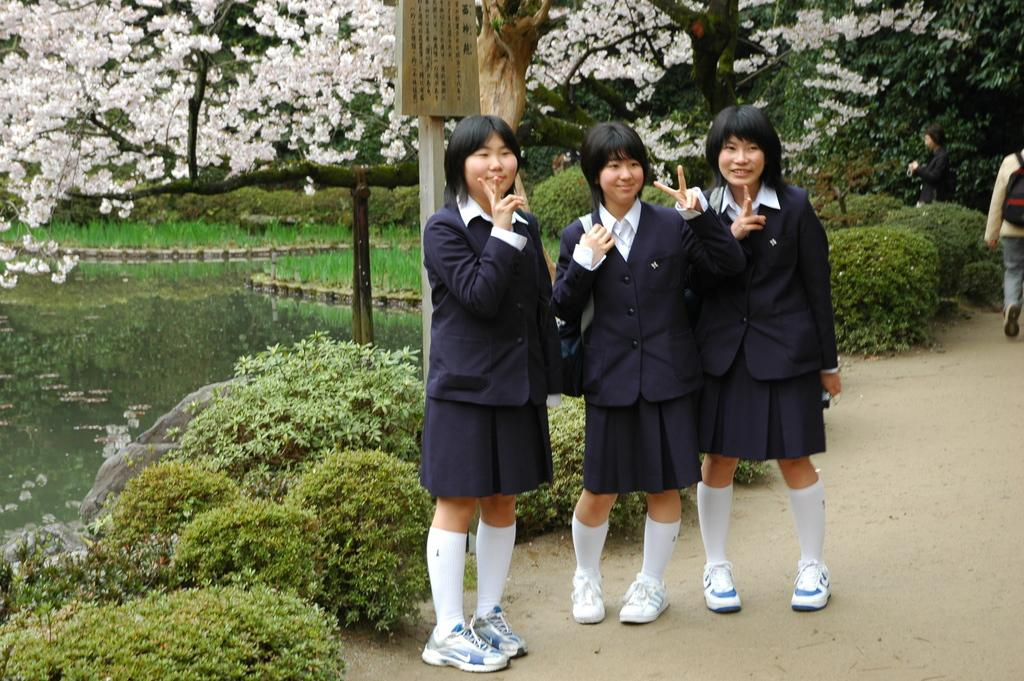How many girls are in the image? There are three girls in the image. What can be said about the appearance of the girls? The girls are beautiful. What are the girls wearing in the image? The girls are wearing black dresses. What type of vegetation is on the left side of the image? There are bushes on the left side of the image. What natural element is visible in the image? Water is visible in the image. What type of glue is being used by the girls in the image? There is no glue present in the image, and the girls are not using any glue. Is there a stove visible in the image? No, there is no stove present in the image. 